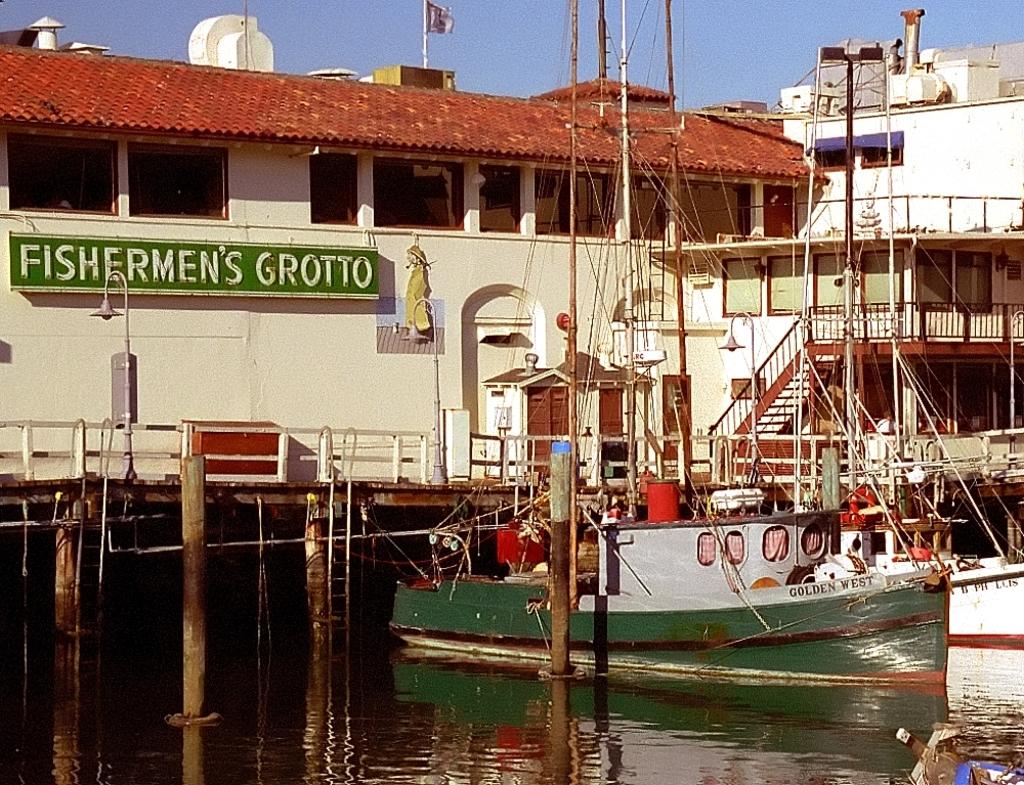What is the name of this location?
Your answer should be very brief. Fishermen's grotto. What is the name of the boat in the water?
Keep it short and to the point. Golden west. 